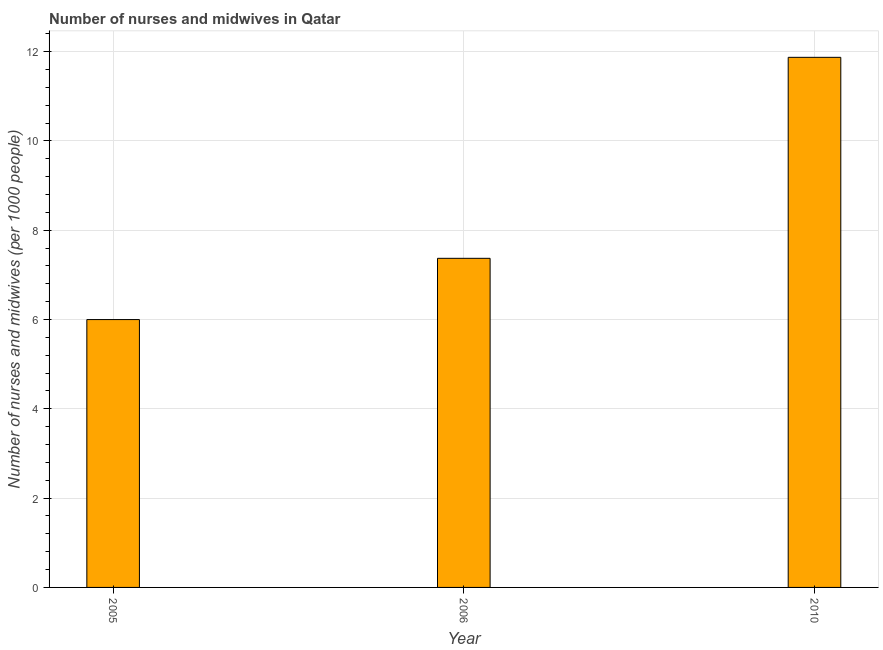Does the graph contain grids?
Your response must be concise. Yes. What is the title of the graph?
Keep it short and to the point. Number of nurses and midwives in Qatar. What is the label or title of the X-axis?
Keep it short and to the point. Year. What is the label or title of the Y-axis?
Offer a terse response. Number of nurses and midwives (per 1000 people). What is the number of nurses and midwives in 2006?
Your answer should be compact. 7.37. Across all years, what is the maximum number of nurses and midwives?
Your response must be concise. 11.87. Across all years, what is the minimum number of nurses and midwives?
Keep it short and to the point. 6. What is the sum of the number of nurses and midwives?
Make the answer very short. 25.25. What is the difference between the number of nurses and midwives in 2006 and 2010?
Offer a terse response. -4.5. What is the average number of nurses and midwives per year?
Give a very brief answer. 8.41. What is the median number of nurses and midwives?
Give a very brief answer. 7.37. In how many years, is the number of nurses and midwives greater than 3.6 ?
Your answer should be compact. 3. What is the ratio of the number of nurses and midwives in 2005 to that in 2006?
Offer a very short reply. 0.81. Is the difference between the number of nurses and midwives in 2005 and 2010 greater than the difference between any two years?
Make the answer very short. Yes. What is the difference between the highest and the second highest number of nurses and midwives?
Keep it short and to the point. 4.5. Is the sum of the number of nurses and midwives in 2005 and 2010 greater than the maximum number of nurses and midwives across all years?
Ensure brevity in your answer.  Yes. What is the difference between the highest and the lowest number of nurses and midwives?
Your answer should be very brief. 5.87. In how many years, is the number of nurses and midwives greater than the average number of nurses and midwives taken over all years?
Provide a short and direct response. 1. How many bars are there?
Offer a very short reply. 3. Are all the bars in the graph horizontal?
Provide a short and direct response. No. What is the Number of nurses and midwives (per 1000 people) of 2005?
Your answer should be compact. 6. What is the Number of nurses and midwives (per 1000 people) of 2006?
Your response must be concise. 7.37. What is the Number of nurses and midwives (per 1000 people) in 2010?
Make the answer very short. 11.87. What is the difference between the Number of nurses and midwives (per 1000 people) in 2005 and 2006?
Make the answer very short. -1.37. What is the difference between the Number of nurses and midwives (per 1000 people) in 2005 and 2010?
Your response must be concise. -5.87. What is the difference between the Number of nurses and midwives (per 1000 people) in 2006 and 2010?
Give a very brief answer. -4.5. What is the ratio of the Number of nurses and midwives (per 1000 people) in 2005 to that in 2006?
Keep it short and to the point. 0.81. What is the ratio of the Number of nurses and midwives (per 1000 people) in 2005 to that in 2010?
Your answer should be compact. 0.51. What is the ratio of the Number of nurses and midwives (per 1000 people) in 2006 to that in 2010?
Your response must be concise. 0.62. 